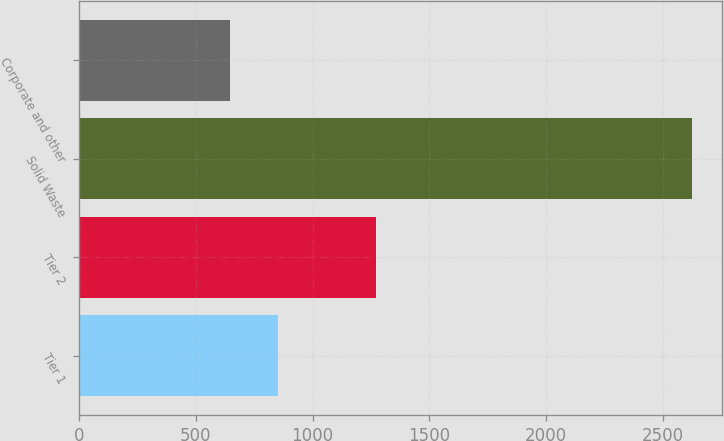Convert chart. <chart><loc_0><loc_0><loc_500><loc_500><bar_chart><fcel>Tier 1<fcel>Tier 2<fcel>Solid Waste<fcel>Corporate and other<nl><fcel>851<fcel>1270<fcel>2625<fcel>645<nl></chart> 